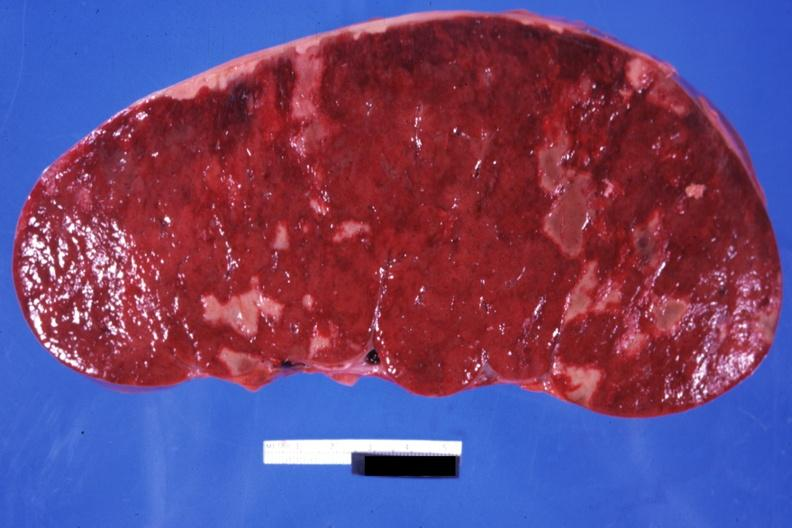s chronic myelogenous leukemia in blast crisis present?
Answer the question using a single word or phrase. Yes 